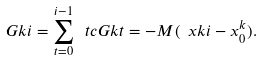<formula> <loc_0><loc_0><loc_500><loc_500>\ G k i = \sum _ { t = 0 } ^ { i - 1 } \ t c G k t = - M ( \ x k i - x _ { 0 } ^ { k } ) .</formula> 